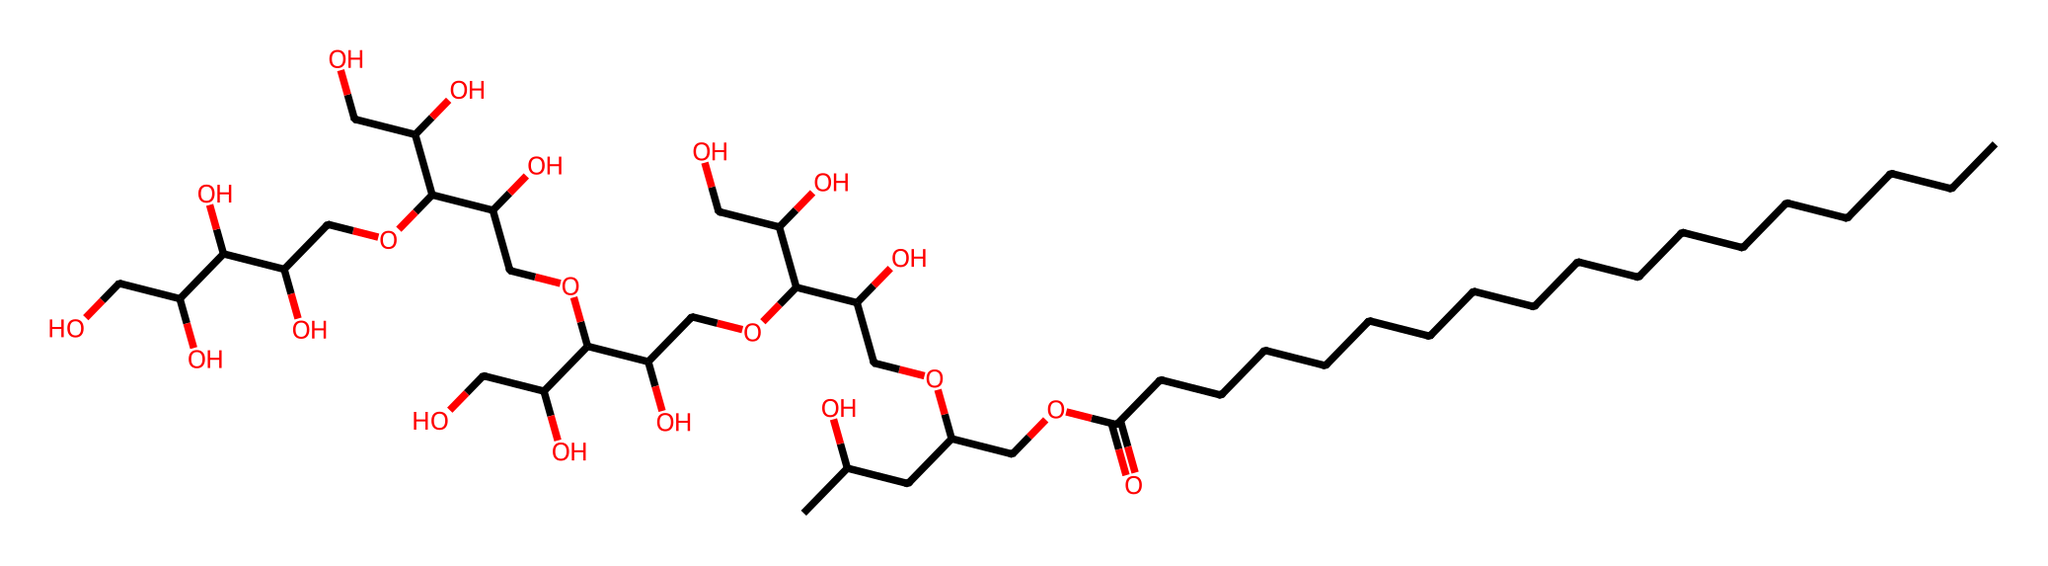What is the main functional group present in polysorbate 20? The main functional group in polysorbate 20 is the ester functional group, indicated by the -O- connected to a carbonyl (C=O) and followed by alkyl chains.
Answer: ester How many hydroxyl groups are present in the structure? By analyzing the structure, we can count the -OH (hydroxyl) groups present. Each carbon chain branching off from the main structure appears to end with a hydroxyl group, totaling 11 hydroxyl groups.
Answer: 11 What is the total number of carbon atoms in polysorbate 20? Counting the carbon atoms in the alkyl chains and the ones in the hydroxyl groups, the total adds up to 20 carbons throughout the entire molecule.
Answer: 20 Which part of the structure provides the hydrophilic characteristic of polysorbate 20? The numerous hydroxyl (-OH) groups attached to the alkyl chains contribute to the molecule’s hydrophilic nature, making it soluble in water.
Answer: hydroxyl groups What type of surfactant is polysorbate 20 classified as? Polysorbate 20 is classified as a non-ionic surfactant because it does not carry any charge in its structure.
Answer: non-ionic How does the length of the carbon chain in polysorbate 20 affect its properties? The long carbon chain leads to the amphiphilic nature of polysorbate 20, which allows it to lower surface tension between oil and water, thus stabilizing emulsions.
Answer: amphiphilic nature What role does polysorbate 20 play in energy drinks consumed by esports players? Polysorbate 20 acts as an emulsifier in energy drinks, helping to mix various ingredients and maintain consistency, crucial for product stability.
Answer: emulsifier 